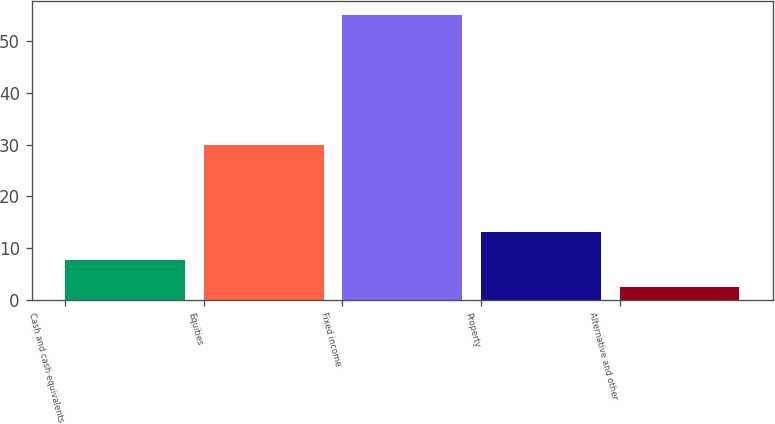Convert chart to OTSL. <chart><loc_0><loc_0><loc_500><loc_500><bar_chart><fcel>Cash and cash equivalents<fcel>Equities<fcel>Fixed income<fcel>Property<fcel>Alternative and other<nl><fcel>7.76<fcel>30<fcel>55<fcel>13.01<fcel>2.51<nl></chart> 